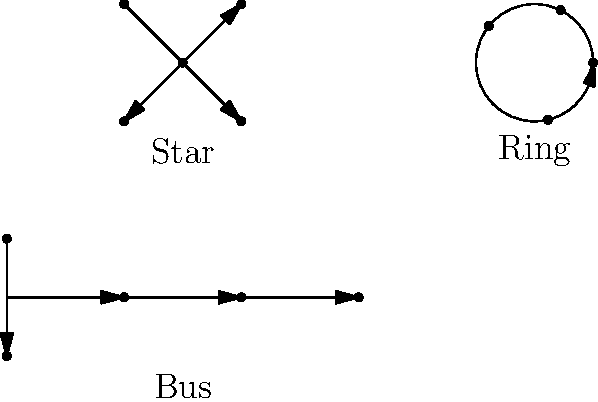As a multimedia journalist covering technology trends in Bihar, you're writing an article about network infrastructure in local businesses. Which network topology type would be most suitable for a small office with 5-10 computers, considering factors like ease of installation, cost-effectiveness, and potential for future expansion? To answer this question, let's analyze the three network topology types shown in the diagram:

1. Star Topology:
   - Central node connects all devices
   - Easy to install and manage
   - Cost-effective for small networks
   - Simple to add new devices
   - If central node fails, entire network goes down

2. Bus Topology:
   - All devices connected to a single cable
   - Inexpensive for small networks
   - Difficult to add new devices
   - Performance degrades with more devices
   - Single cable failure affects entire network

3. Ring Topology:
   - Devices connected in a circular pattern
   - Efficient data transmission for large networks
   - Complex installation and management
   - Difficult to add or remove devices
   - Single device failure can disrupt the entire network

For a small office with 5-10 computers, considering ease of installation, cost-effectiveness, and potential for future expansion, the star topology would be most suitable because:

1. It's easy to install and manage, which is ideal for small businesses without dedicated IT staff.
2. It's cost-effective for small networks, fitting the budget constraints of local businesses in Bihar.
3. Adding new devices is simple, allowing for future expansion as the business grows.
4. If one device fails, it doesn't affect the entire network, ensuring business continuity.

While the central node is a single point of failure, the benefits outweigh this drawback for a small office setting.
Answer: Star topology 